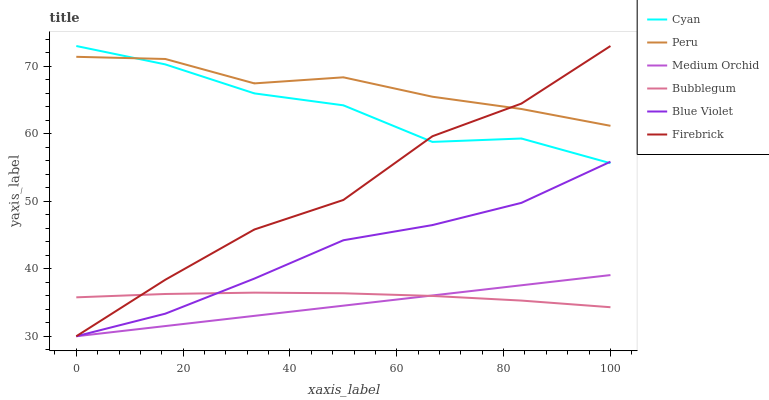Does Medium Orchid have the minimum area under the curve?
Answer yes or no. Yes. Does Peru have the maximum area under the curve?
Answer yes or no. Yes. Does Bubblegum have the minimum area under the curve?
Answer yes or no. No. Does Bubblegum have the maximum area under the curve?
Answer yes or no. No. Is Medium Orchid the smoothest?
Answer yes or no. Yes. Is Cyan the roughest?
Answer yes or no. Yes. Is Bubblegum the smoothest?
Answer yes or no. No. Is Bubblegum the roughest?
Answer yes or no. No. Does Firebrick have the lowest value?
Answer yes or no. Yes. Does Bubblegum have the lowest value?
Answer yes or no. No. Does Cyan have the highest value?
Answer yes or no. Yes. Does Medium Orchid have the highest value?
Answer yes or no. No. Is Blue Violet less than Peru?
Answer yes or no. Yes. Is Cyan greater than Medium Orchid?
Answer yes or no. Yes. Does Bubblegum intersect Medium Orchid?
Answer yes or no. Yes. Is Bubblegum less than Medium Orchid?
Answer yes or no. No. Is Bubblegum greater than Medium Orchid?
Answer yes or no. No. Does Blue Violet intersect Peru?
Answer yes or no. No. 